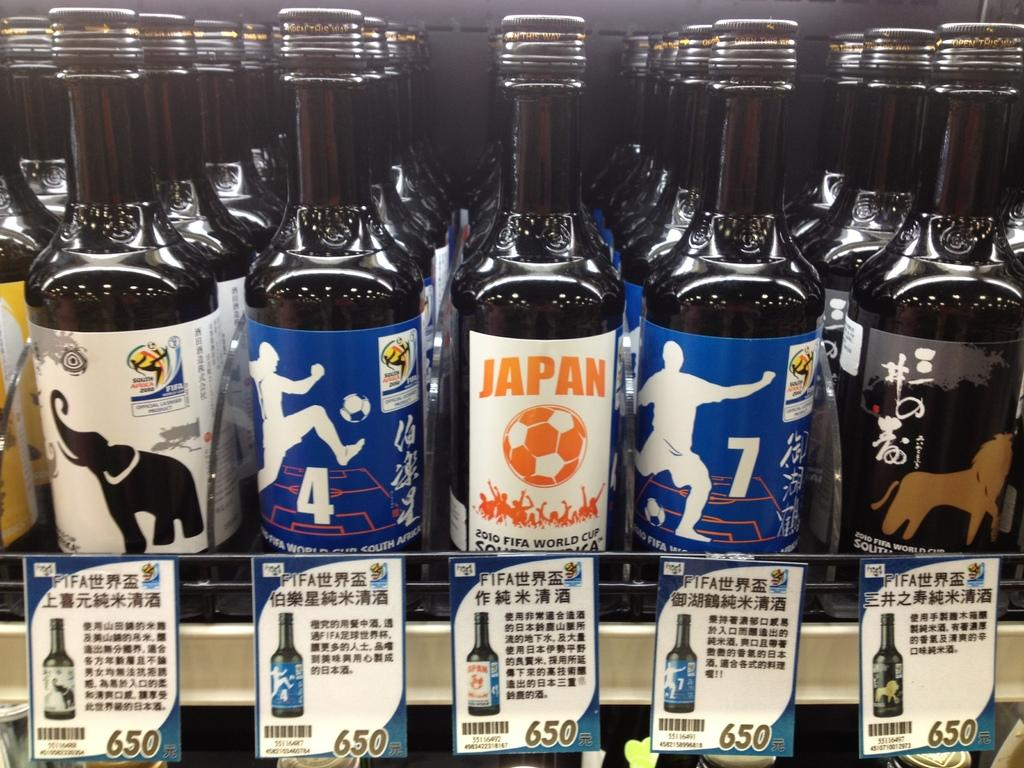What objects are in the image? There is a group of bottles in the image. Where are the bottles located? The bottles are on a shelf. What type of crayon can be seen in the image? There is no crayon present in the image. 